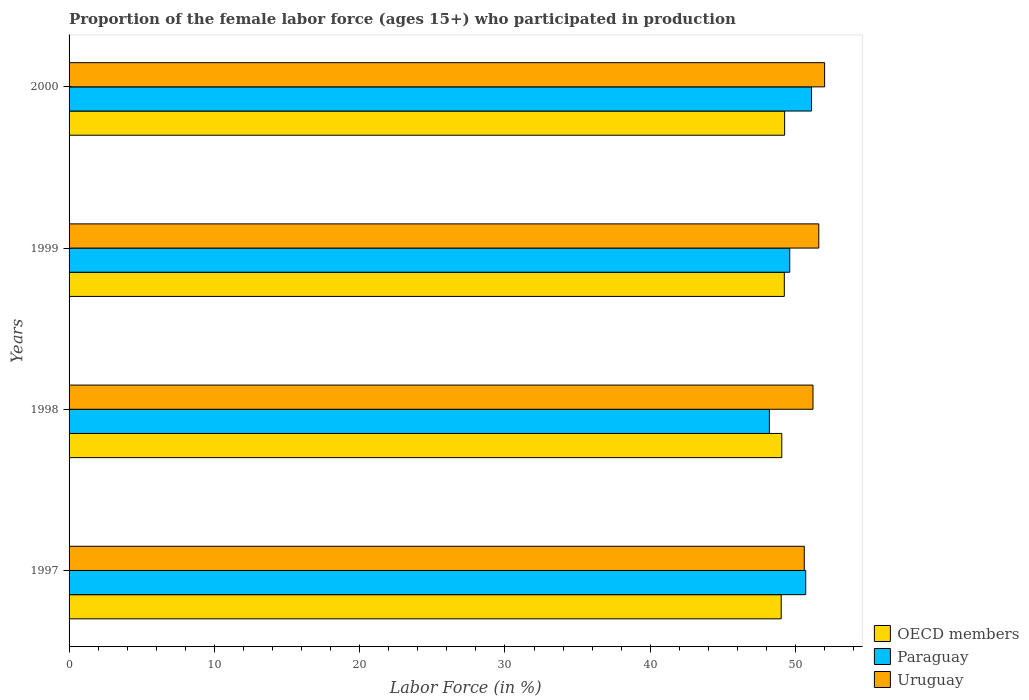Are the number of bars per tick equal to the number of legend labels?
Give a very brief answer. Yes. Are the number of bars on each tick of the Y-axis equal?
Your response must be concise. Yes. How many bars are there on the 4th tick from the top?
Offer a very short reply. 3. What is the proportion of the female labor force who participated in production in OECD members in 2000?
Offer a very short reply. 49.25. Across all years, what is the maximum proportion of the female labor force who participated in production in OECD members?
Keep it short and to the point. 49.25. Across all years, what is the minimum proportion of the female labor force who participated in production in Uruguay?
Your answer should be very brief. 50.6. In which year was the proportion of the female labor force who participated in production in Paraguay maximum?
Your answer should be very brief. 2000. What is the total proportion of the female labor force who participated in production in OECD members in the graph?
Your answer should be very brief. 196.54. What is the difference between the proportion of the female labor force who participated in production in OECD members in 1998 and that in 1999?
Provide a short and direct response. -0.17. What is the difference between the proportion of the female labor force who participated in production in Paraguay in 2000 and the proportion of the female labor force who participated in production in Uruguay in 1998?
Offer a terse response. -0.1. What is the average proportion of the female labor force who participated in production in OECD members per year?
Offer a very short reply. 49.14. In the year 1998, what is the difference between the proportion of the female labor force who participated in production in Uruguay and proportion of the female labor force who participated in production in Paraguay?
Keep it short and to the point. 3. In how many years, is the proportion of the female labor force who participated in production in OECD members greater than 46 %?
Your answer should be compact. 4. What is the ratio of the proportion of the female labor force who participated in production in Uruguay in 1998 to that in 2000?
Your answer should be very brief. 0.98. Is the difference between the proportion of the female labor force who participated in production in Uruguay in 1997 and 2000 greater than the difference between the proportion of the female labor force who participated in production in Paraguay in 1997 and 2000?
Your answer should be compact. No. What is the difference between the highest and the second highest proportion of the female labor force who participated in production in OECD members?
Your answer should be very brief. 0.02. What is the difference between the highest and the lowest proportion of the female labor force who participated in production in OECD members?
Provide a succinct answer. 0.24. In how many years, is the proportion of the female labor force who participated in production in Paraguay greater than the average proportion of the female labor force who participated in production in Paraguay taken over all years?
Provide a short and direct response. 2. Is the sum of the proportion of the female labor force who participated in production in Paraguay in 1999 and 2000 greater than the maximum proportion of the female labor force who participated in production in Uruguay across all years?
Your answer should be very brief. Yes. What does the 2nd bar from the top in 2000 represents?
Ensure brevity in your answer.  Paraguay. What does the 1st bar from the bottom in 1998 represents?
Provide a succinct answer. OECD members. Is it the case that in every year, the sum of the proportion of the female labor force who participated in production in Uruguay and proportion of the female labor force who participated in production in Paraguay is greater than the proportion of the female labor force who participated in production in OECD members?
Offer a very short reply. Yes. How many years are there in the graph?
Give a very brief answer. 4. What is the difference between two consecutive major ticks on the X-axis?
Your answer should be very brief. 10. Are the values on the major ticks of X-axis written in scientific E-notation?
Keep it short and to the point. No. Does the graph contain any zero values?
Offer a terse response. No. Does the graph contain grids?
Ensure brevity in your answer.  No. Where does the legend appear in the graph?
Your response must be concise. Bottom right. How are the legend labels stacked?
Your answer should be very brief. Vertical. What is the title of the graph?
Provide a succinct answer. Proportion of the female labor force (ages 15+) who participated in production. Does "Sudan" appear as one of the legend labels in the graph?
Give a very brief answer. No. What is the Labor Force (in %) of OECD members in 1997?
Provide a succinct answer. 49.01. What is the Labor Force (in %) in Paraguay in 1997?
Offer a very short reply. 50.7. What is the Labor Force (in %) in Uruguay in 1997?
Give a very brief answer. 50.6. What is the Labor Force (in %) of OECD members in 1998?
Offer a terse response. 49.05. What is the Labor Force (in %) in Paraguay in 1998?
Ensure brevity in your answer.  48.2. What is the Labor Force (in %) of Uruguay in 1998?
Make the answer very short. 51.2. What is the Labor Force (in %) in OECD members in 1999?
Your answer should be very brief. 49.23. What is the Labor Force (in %) of Paraguay in 1999?
Provide a succinct answer. 49.6. What is the Labor Force (in %) of Uruguay in 1999?
Provide a short and direct response. 51.6. What is the Labor Force (in %) of OECD members in 2000?
Your answer should be very brief. 49.25. What is the Labor Force (in %) of Paraguay in 2000?
Your answer should be very brief. 51.1. Across all years, what is the maximum Labor Force (in %) in OECD members?
Your answer should be compact. 49.25. Across all years, what is the maximum Labor Force (in %) in Paraguay?
Provide a succinct answer. 51.1. Across all years, what is the minimum Labor Force (in %) in OECD members?
Provide a short and direct response. 49.01. Across all years, what is the minimum Labor Force (in %) of Paraguay?
Your answer should be very brief. 48.2. Across all years, what is the minimum Labor Force (in %) in Uruguay?
Ensure brevity in your answer.  50.6. What is the total Labor Force (in %) in OECD members in the graph?
Your answer should be very brief. 196.54. What is the total Labor Force (in %) of Paraguay in the graph?
Your answer should be compact. 199.6. What is the total Labor Force (in %) of Uruguay in the graph?
Your answer should be very brief. 205.4. What is the difference between the Labor Force (in %) of OECD members in 1997 and that in 1998?
Make the answer very short. -0.04. What is the difference between the Labor Force (in %) in Paraguay in 1997 and that in 1998?
Give a very brief answer. 2.5. What is the difference between the Labor Force (in %) of Uruguay in 1997 and that in 1998?
Provide a succinct answer. -0.6. What is the difference between the Labor Force (in %) in OECD members in 1997 and that in 1999?
Give a very brief answer. -0.21. What is the difference between the Labor Force (in %) of Paraguay in 1997 and that in 1999?
Your answer should be very brief. 1.1. What is the difference between the Labor Force (in %) of OECD members in 1997 and that in 2000?
Give a very brief answer. -0.24. What is the difference between the Labor Force (in %) of Uruguay in 1997 and that in 2000?
Offer a terse response. -1.4. What is the difference between the Labor Force (in %) in OECD members in 1998 and that in 1999?
Your answer should be compact. -0.17. What is the difference between the Labor Force (in %) in Paraguay in 1998 and that in 1999?
Your answer should be compact. -1.4. What is the difference between the Labor Force (in %) in Uruguay in 1998 and that in 1999?
Make the answer very short. -0.4. What is the difference between the Labor Force (in %) of OECD members in 1998 and that in 2000?
Your answer should be compact. -0.2. What is the difference between the Labor Force (in %) in OECD members in 1999 and that in 2000?
Your answer should be compact. -0.02. What is the difference between the Labor Force (in %) of OECD members in 1997 and the Labor Force (in %) of Paraguay in 1998?
Your answer should be very brief. 0.81. What is the difference between the Labor Force (in %) of OECD members in 1997 and the Labor Force (in %) of Uruguay in 1998?
Ensure brevity in your answer.  -2.19. What is the difference between the Labor Force (in %) of Paraguay in 1997 and the Labor Force (in %) of Uruguay in 1998?
Your answer should be very brief. -0.5. What is the difference between the Labor Force (in %) in OECD members in 1997 and the Labor Force (in %) in Paraguay in 1999?
Your answer should be compact. -0.59. What is the difference between the Labor Force (in %) in OECD members in 1997 and the Labor Force (in %) in Uruguay in 1999?
Offer a very short reply. -2.59. What is the difference between the Labor Force (in %) of OECD members in 1997 and the Labor Force (in %) of Paraguay in 2000?
Make the answer very short. -2.09. What is the difference between the Labor Force (in %) in OECD members in 1997 and the Labor Force (in %) in Uruguay in 2000?
Keep it short and to the point. -2.99. What is the difference between the Labor Force (in %) in OECD members in 1998 and the Labor Force (in %) in Paraguay in 1999?
Your answer should be very brief. -0.55. What is the difference between the Labor Force (in %) of OECD members in 1998 and the Labor Force (in %) of Uruguay in 1999?
Ensure brevity in your answer.  -2.55. What is the difference between the Labor Force (in %) in Paraguay in 1998 and the Labor Force (in %) in Uruguay in 1999?
Offer a terse response. -3.4. What is the difference between the Labor Force (in %) in OECD members in 1998 and the Labor Force (in %) in Paraguay in 2000?
Make the answer very short. -2.05. What is the difference between the Labor Force (in %) in OECD members in 1998 and the Labor Force (in %) in Uruguay in 2000?
Give a very brief answer. -2.95. What is the difference between the Labor Force (in %) in OECD members in 1999 and the Labor Force (in %) in Paraguay in 2000?
Give a very brief answer. -1.87. What is the difference between the Labor Force (in %) in OECD members in 1999 and the Labor Force (in %) in Uruguay in 2000?
Your response must be concise. -2.77. What is the difference between the Labor Force (in %) of Paraguay in 1999 and the Labor Force (in %) of Uruguay in 2000?
Your answer should be compact. -2.4. What is the average Labor Force (in %) of OECD members per year?
Ensure brevity in your answer.  49.14. What is the average Labor Force (in %) in Paraguay per year?
Give a very brief answer. 49.9. What is the average Labor Force (in %) of Uruguay per year?
Your answer should be very brief. 51.35. In the year 1997, what is the difference between the Labor Force (in %) in OECD members and Labor Force (in %) in Paraguay?
Keep it short and to the point. -1.69. In the year 1997, what is the difference between the Labor Force (in %) in OECD members and Labor Force (in %) in Uruguay?
Provide a succinct answer. -1.59. In the year 1997, what is the difference between the Labor Force (in %) of Paraguay and Labor Force (in %) of Uruguay?
Offer a terse response. 0.1. In the year 1998, what is the difference between the Labor Force (in %) of OECD members and Labor Force (in %) of Paraguay?
Provide a short and direct response. 0.85. In the year 1998, what is the difference between the Labor Force (in %) of OECD members and Labor Force (in %) of Uruguay?
Your answer should be compact. -2.15. In the year 1998, what is the difference between the Labor Force (in %) in Paraguay and Labor Force (in %) in Uruguay?
Make the answer very short. -3. In the year 1999, what is the difference between the Labor Force (in %) in OECD members and Labor Force (in %) in Paraguay?
Make the answer very short. -0.37. In the year 1999, what is the difference between the Labor Force (in %) of OECD members and Labor Force (in %) of Uruguay?
Provide a short and direct response. -2.37. In the year 2000, what is the difference between the Labor Force (in %) in OECD members and Labor Force (in %) in Paraguay?
Make the answer very short. -1.85. In the year 2000, what is the difference between the Labor Force (in %) in OECD members and Labor Force (in %) in Uruguay?
Keep it short and to the point. -2.75. In the year 2000, what is the difference between the Labor Force (in %) in Paraguay and Labor Force (in %) in Uruguay?
Your answer should be very brief. -0.9. What is the ratio of the Labor Force (in %) of OECD members in 1997 to that in 1998?
Your response must be concise. 1. What is the ratio of the Labor Force (in %) in Paraguay in 1997 to that in 1998?
Provide a succinct answer. 1.05. What is the ratio of the Labor Force (in %) in Uruguay in 1997 to that in 1998?
Give a very brief answer. 0.99. What is the ratio of the Labor Force (in %) in OECD members in 1997 to that in 1999?
Your response must be concise. 1. What is the ratio of the Labor Force (in %) of Paraguay in 1997 to that in 1999?
Offer a terse response. 1.02. What is the ratio of the Labor Force (in %) in Uruguay in 1997 to that in 1999?
Ensure brevity in your answer.  0.98. What is the ratio of the Labor Force (in %) of OECD members in 1997 to that in 2000?
Your answer should be very brief. 1. What is the ratio of the Labor Force (in %) in Uruguay in 1997 to that in 2000?
Your answer should be very brief. 0.97. What is the ratio of the Labor Force (in %) of Paraguay in 1998 to that in 1999?
Your answer should be compact. 0.97. What is the ratio of the Labor Force (in %) in Uruguay in 1998 to that in 1999?
Keep it short and to the point. 0.99. What is the ratio of the Labor Force (in %) in OECD members in 1998 to that in 2000?
Provide a short and direct response. 1. What is the ratio of the Labor Force (in %) of Paraguay in 1998 to that in 2000?
Provide a succinct answer. 0.94. What is the ratio of the Labor Force (in %) of Uruguay in 1998 to that in 2000?
Offer a very short reply. 0.98. What is the ratio of the Labor Force (in %) in OECD members in 1999 to that in 2000?
Keep it short and to the point. 1. What is the ratio of the Labor Force (in %) of Paraguay in 1999 to that in 2000?
Offer a very short reply. 0.97. What is the ratio of the Labor Force (in %) in Uruguay in 1999 to that in 2000?
Keep it short and to the point. 0.99. What is the difference between the highest and the second highest Labor Force (in %) of OECD members?
Your response must be concise. 0.02. What is the difference between the highest and the second highest Labor Force (in %) of Paraguay?
Ensure brevity in your answer.  0.4. What is the difference between the highest and the lowest Labor Force (in %) of OECD members?
Your answer should be very brief. 0.24. What is the difference between the highest and the lowest Labor Force (in %) of Paraguay?
Keep it short and to the point. 2.9. What is the difference between the highest and the lowest Labor Force (in %) in Uruguay?
Your response must be concise. 1.4. 